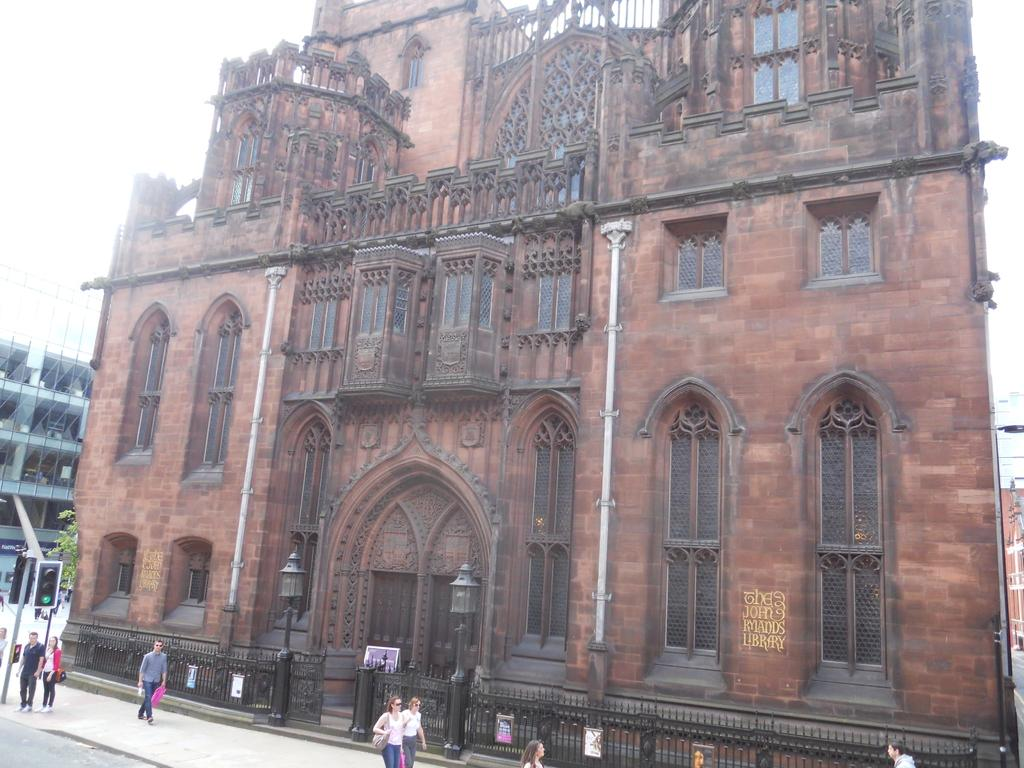What is the main structure in the image? There is a building in the center of the image. What is happening on the road in the image? There are people walking on the road. What is used to control traffic in the image? There is a traffic signal in the image. What is separating the road from the building? There is a fencing in the image. What can be seen above the building and fencing? The sky is visible at the top of the image. Where are the apples being delivered in the scene? There are no apples or delivery mentioned in the image; it only features a building, people walking, a traffic signal, fencing, and the sky. 